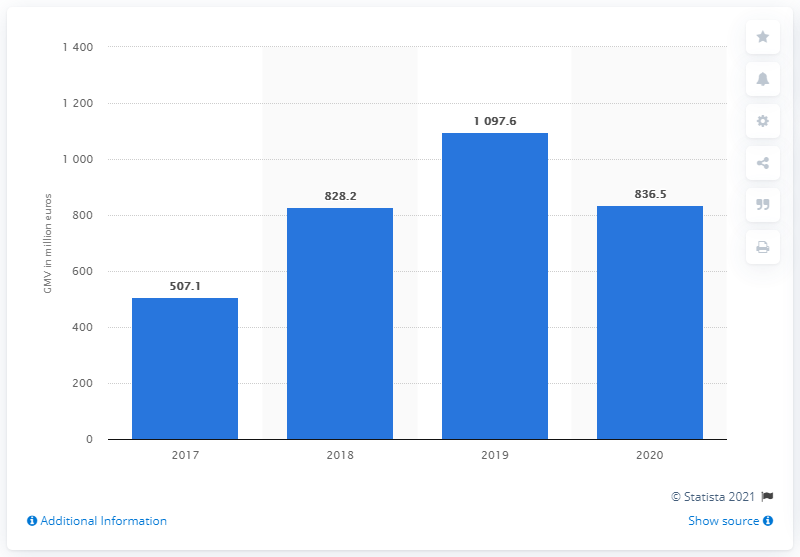Highlight a few significant elements in this photo. Jumia generated a gross merchandise volume of 836.5 in 2020. Jumia's Gross Merchandise Volume (GMV) in 2019 was 1097.6 million dollars. 